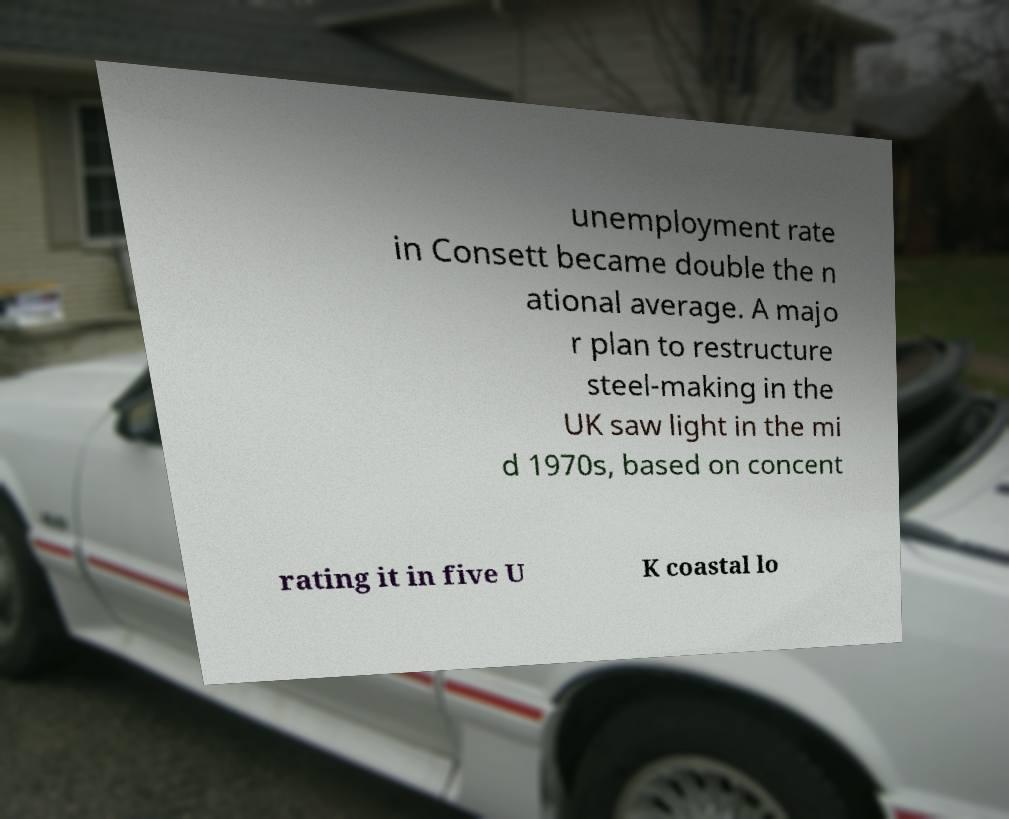Could you assist in decoding the text presented in this image and type it out clearly? unemployment rate in Consett became double the n ational average. A majo r plan to restructure steel-making in the UK saw light in the mi d 1970s, based on concent rating it in five U K coastal lo 